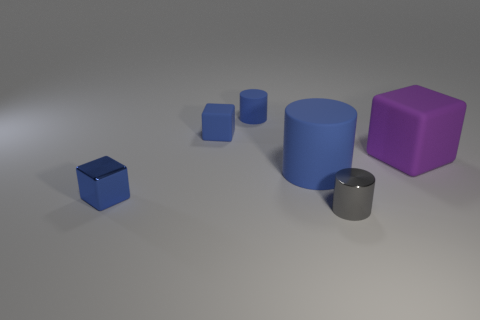Subtract all brown blocks. Subtract all cyan balls. How many blocks are left? 3 Add 2 tiny objects. How many objects exist? 8 Subtract all small gray cylinders. Subtract all shiny objects. How many objects are left? 3 Add 4 blue matte blocks. How many blue matte blocks are left? 5 Add 3 yellow cylinders. How many yellow cylinders exist? 3 Subtract 1 blue cubes. How many objects are left? 5 